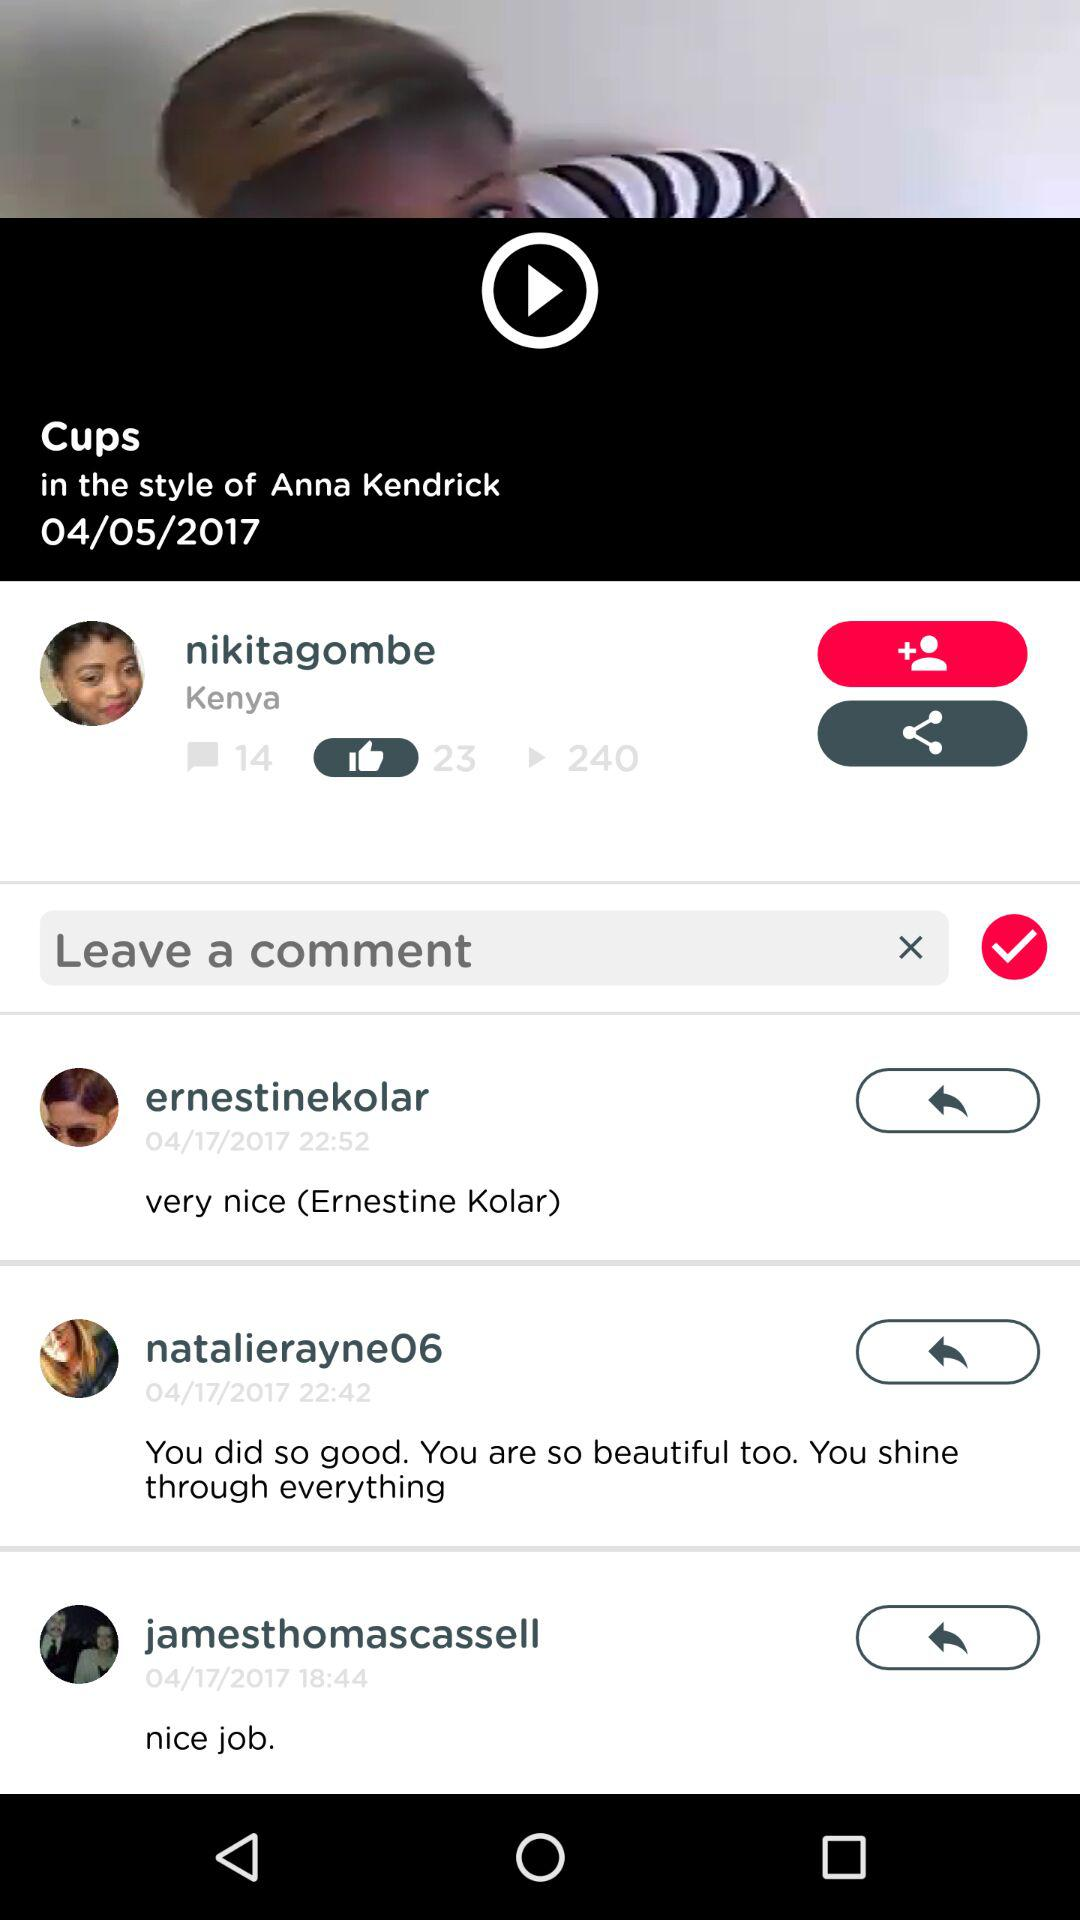How many comments are shown there? There are 14 comments. 